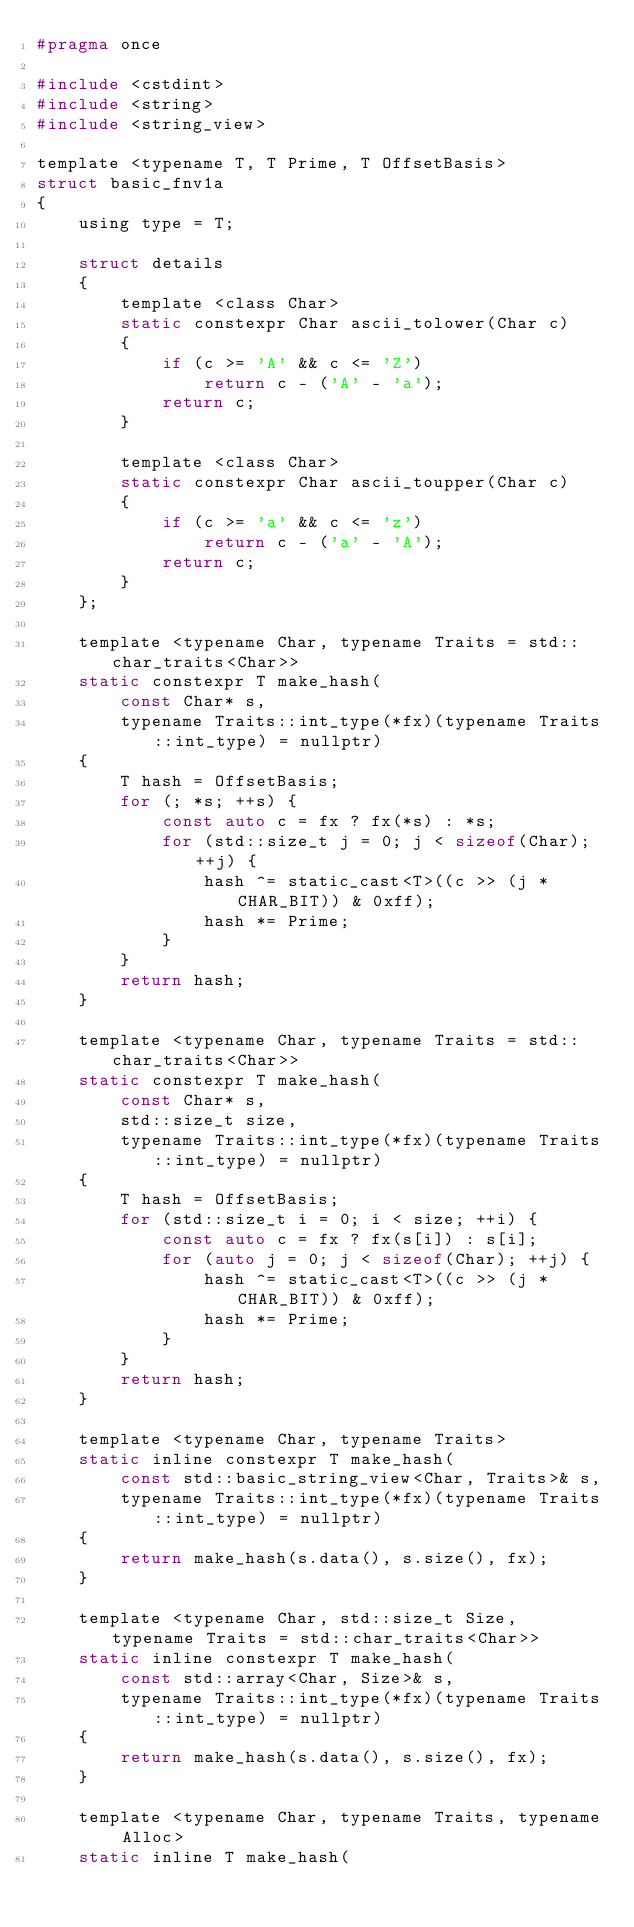<code> <loc_0><loc_0><loc_500><loc_500><_C_>#pragma once

#include <cstdint>
#include <string>
#include <string_view>

template <typename T, T Prime, T OffsetBasis>
struct basic_fnv1a
{
    using type = T;

    struct details
    {
        template <class Char>
        static constexpr Char ascii_tolower(Char c)
        {
            if (c >= 'A' && c <= 'Z')
                return c - ('A' - 'a');
            return c;
        }

        template <class Char>
        static constexpr Char ascii_toupper(Char c)
        {
            if (c >= 'a' && c <= 'z')
                return c - ('a' - 'A');
            return c;
        }
    };

    template <typename Char, typename Traits = std::char_traits<Char>>
    static constexpr T make_hash(
        const Char* s,
        typename Traits::int_type(*fx)(typename Traits::int_type) = nullptr)
    {
        T hash = OffsetBasis;
        for (; *s; ++s) {
            const auto c = fx ? fx(*s) : *s;
            for (std::size_t j = 0; j < sizeof(Char); ++j) {
                hash ^= static_cast<T>((c >> (j * CHAR_BIT)) & 0xff);
                hash *= Prime;
            }
        }
        return hash;
    }

    template <typename Char, typename Traits = std::char_traits<Char>>
    static constexpr T make_hash(
        const Char* s,
        std::size_t size,
        typename Traits::int_type(*fx)(typename Traits::int_type) = nullptr)
    {
        T hash = OffsetBasis;
        for (std::size_t i = 0; i < size; ++i) {
            const auto c = fx ? fx(s[i]) : s[i];
            for (auto j = 0; j < sizeof(Char); ++j) {
                hash ^= static_cast<T>((c >> (j * CHAR_BIT)) & 0xff);
                hash *= Prime;
            }
        }
        return hash;
    }

    template <typename Char, typename Traits>
    static inline constexpr T make_hash(
        const std::basic_string_view<Char, Traits>& s,
        typename Traits::int_type(*fx)(typename Traits::int_type) = nullptr)
    {
        return make_hash(s.data(), s.size(), fx);
    }

    template <typename Char, std::size_t Size, typename Traits = std::char_traits<Char>>
    static inline constexpr T make_hash(
        const std::array<Char, Size>& s,
        typename Traits::int_type(*fx)(typename Traits::int_type) = nullptr)
    {
        return make_hash(s.data(), s.size(), fx);
    }

    template <typename Char, typename Traits, typename Alloc>
    static inline T make_hash(</code> 